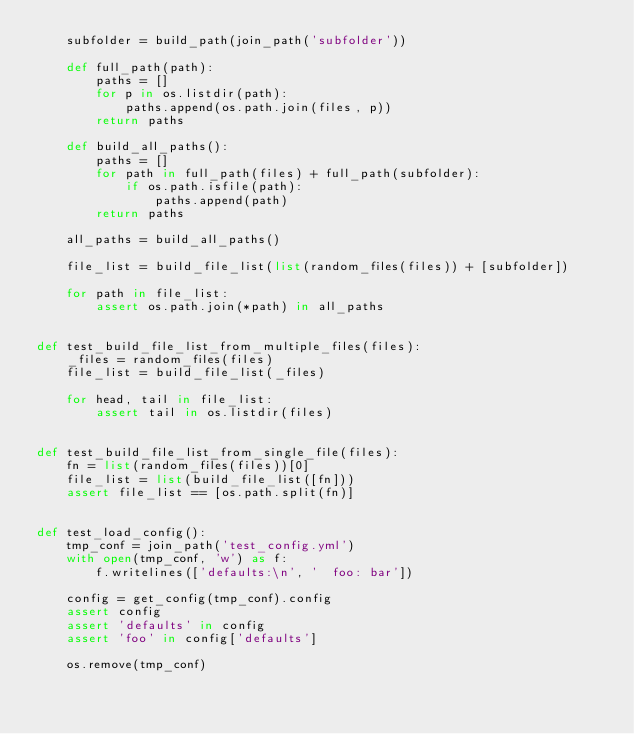Convert code to text. <code><loc_0><loc_0><loc_500><loc_500><_Python_>    subfolder = build_path(join_path('subfolder'))

    def full_path(path):
        paths = []
        for p in os.listdir(path):
            paths.append(os.path.join(files, p))
        return paths

    def build_all_paths():
        paths = []
        for path in full_path(files) + full_path(subfolder):
            if os.path.isfile(path):
                paths.append(path)
        return paths

    all_paths = build_all_paths()

    file_list = build_file_list(list(random_files(files)) + [subfolder])

    for path in file_list:
        assert os.path.join(*path) in all_paths


def test_build_file_list_from_multiple_files(files):
    _files = random_files(files)
    file_list = build_file_list(_files)

    for head, tail in file_list:
        assert tail in os.listdir(files)


def test_build_file_list_from_single_file(files):
    fn = list(random_files(files))[0]
    file_list = list(build_file_list([fn]))
    assert file_list == [os.path.split(fn)]


def test_load_config():
    tmp_conf = join_path('test_config.yml')
    with open(tmp_conf, 'w') as f:
        f.writelines(['defaults:\n', '  foo: bar'])

    config = get_config(tmp_conf).config
    assert config
    assert 'defaults' in config
    assert 'foo' in config['defaults']

    os.remove(tmp_conf)
</code> 